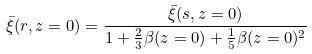Convert formula to latex. <formula><loc_0><loc_0><loc_500><loc_500>\bar { \xi } ( r , z = 0 ) = \frac { \bar { \xi } ( s , z = 0 ) } { 1 + \frac { 2 } { 3 } \beta ( z = 0 ) + \frac { 1 } { 5 } \beta ( z = 0 ) ^ { 2 } }</formula> 